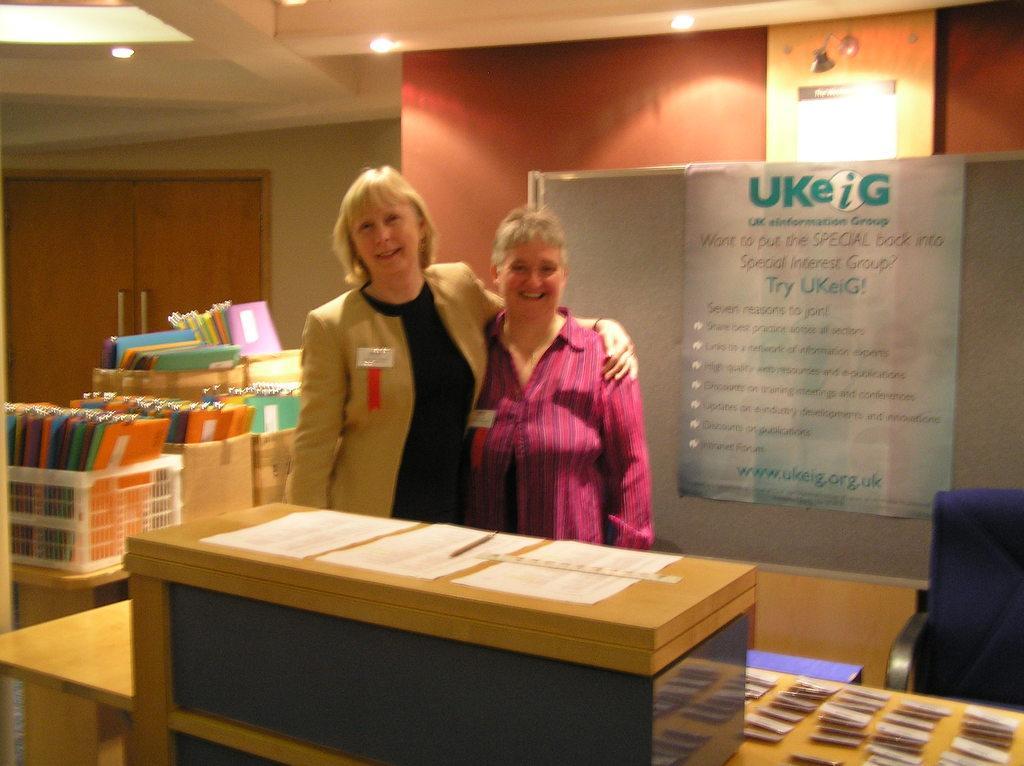In one or two sentences, can you explain what this image depicts? In this image I see 2 women and both of them are smiling, I can also see that there is a table in front and there are few papers on it. In the background I see the wall, lights and lot of files over here. 